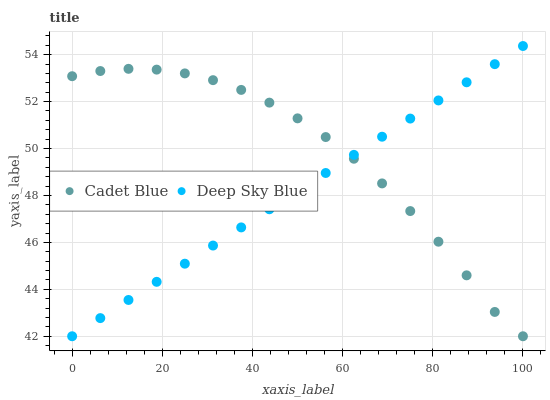Does Deep Sky Blue have the minimum area under the curve?
Answer yes or no. Yes. Does Cadet Blue have the maximum area under the curve?
Answer yes or no. Yes. Does Deep Sky Blue have the maximum area under the curve?
Answer yes or no. No. Is Deep Sky Blue the smoothest?
Answer yes or no. Yes. Is Cadet Blue the roughest?
Answer yes or no. Yes. Is Deep Sky Blue the roughest?
Answer yes or no. No. Does Cadet Blue have the lowest value?
Answer yes or no. Yes. Does Deep Sky Blue have the highest value?
Answer yes or no. Yes. Does Deep Sky Blue intersect Cadet Blue?
Answer yes or no. Yes. Is Deep Sky Blue less than Cadet Blue?
Answer yes or no. No. Is Deep Sky Blue greater than Cadet Blue?
Answer yes or no. No. 